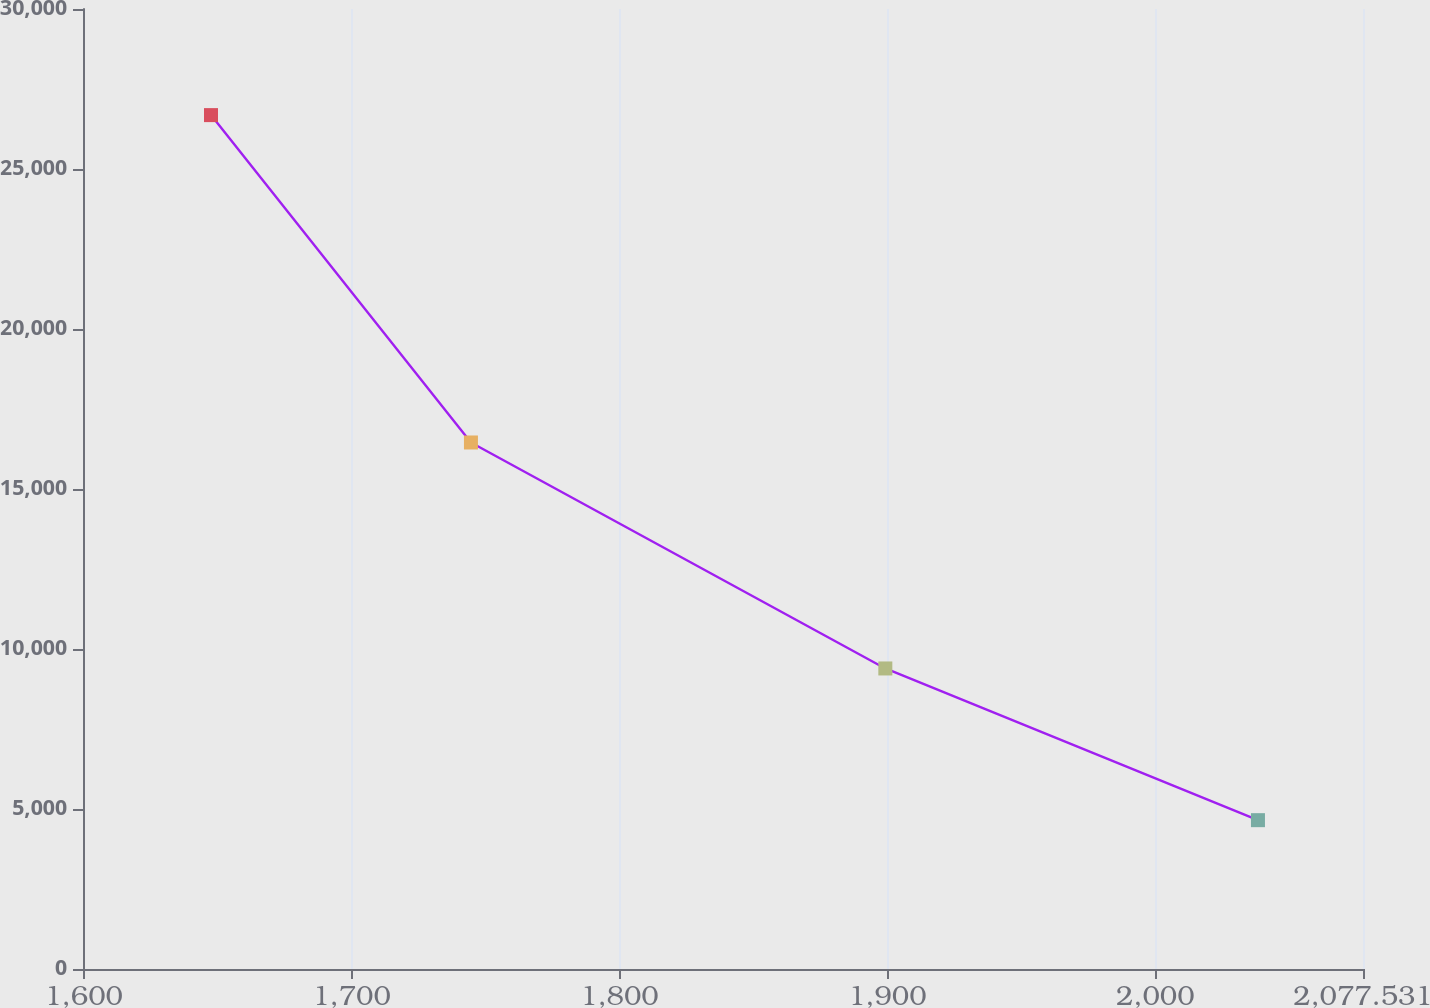<chart> <loc_0><loc_0><loc_500><loc_500><line_chart><ecel><fcel>Operating Leases<nl><fcel>1647.52<fcel>26683.7<nl><fcel>1744.55<fcel>16453.3<nl><fcel>1899.23<fcel>9391.68<nl><fcel>2038.32<fcel>4650.74<nl><fcel>2125.31<fcel>1329.44<nl></chart> 